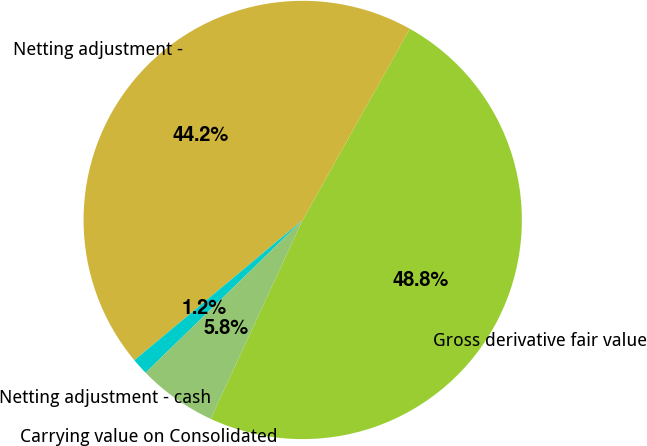Convert chart to OTSL. <chart><loc_0><loc_0><loc_500><loc_500><pie_chart><fcel>Gross derivative fair value<fcel>Netting adjustment -<fcel>Netting adjustment - cash<fcel>Carrying value on Consolidated<nl><fcel>48.78%<fcel>44.18%<fcel>1.22%<fcel>5.82%<nl></chart> 